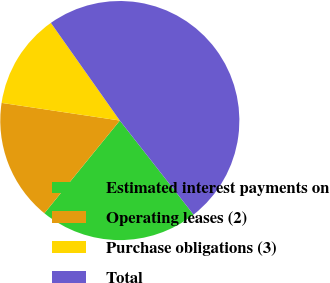Convert chart to OTSL. <chart><loc_0><loc_0><loc_500><loc_500><pie_chart><fcel>Estimated interest payments on<fcel>Operating leases (2)<fcel>Purchase obligations (3)<fcel>Total<nl><fcel>21.45%<fcel>16.49%<fcel>12.86%<fcel>49.2%<nl></chart> 